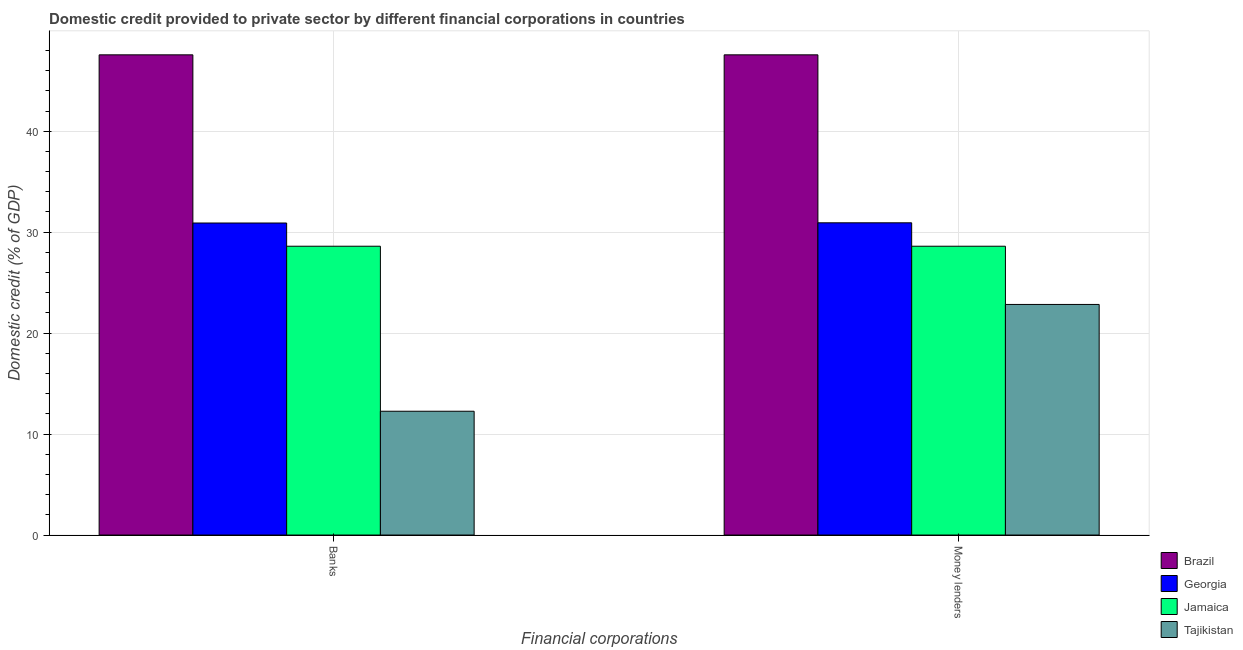How many different coloured bars are there?
Give a very brief answer. 4. Are the number of bars per tick equal to the number of legend labels?
Ensure brevity in your answer.  Yes. Are the number of bars on each tick of the X-axis equal?
Your answer should be compact. Yes. How many bars are there on the 1st tick from the left?
Keep it short and to the point. 4. How many bars are there on the 2nd tick from the right?
Your response must be concise. 4. What is the label of the 2nd group of bars from the left?
Your response must be concise. Money lenders. What is the domestic credit provided by money lenders in Tajikistan?
Your response must be concise. 22.84. Across all countries, what is the maximum domestic credit provided by money lenders?
Provide a short and direct response. 47.56. Across all countries, what is the minimum domestic credit provided by banks?
Make the answer very short. 12.26. In which country was the domestic credit provided by banks maximum?
Your answer should be compact. Brazil. In which country was the domestic credit provided by money lenders minimum?
Ensure brevity in your answer.  Tajikistan. What is the total domestic credit provided by banks in the graph?
Ensure brevity in your answer.  119.34. What is the difference between the domestic credit provided by banks in Tajikistan and that in Brazil?
Make the answer very short. -35.3. What is the difference between the domestic credit provided by money lenders in Jamaica and the domestic credit provided by banks in Georgia?
Give a very brief answer. -2.3. What is the average domestic credit provided by money lenders per country?
Your response must be concise. 32.48. What is the difference between the domestic credit provided by money lenders and domestic credit provided by banks in Jamaica?
Your answer should be compact. 0. What is the ratio of the domestic credit provided by banks in Georgia to that in Tajikistan?
Give a very brief answer. 2.52. Is the domestic credit provided by money lenders in Tajikistan less than that in Brazil?
Your response must be concise. Yes. What does the 4th bar from the right in Banks represents?
Make the answer very short. Brazil. How many countries are there in the graph?
Provide a succinct answer. 4. Are the values on the major ticks of Y-axis written in scientific E-notation?
Keep it short and to the point. No. Does the graph contain grids?
Make the answer very short. Yes. How many legend labels are there?
Provide a short and direct response. 4. What is the title of the graph?
Your answer should be very brief. Domestic credit provided to private sector by different financial corporations in countries. What is the label or title of the X-axis?
Keep it short and to the point. Financial corporations. What is the label or title of the Y-axis?
Your answer should be compact. Domestic credit (% of GDP). What is the Domestic credit (% of GDP) in Brazil in Banks?
Your answer should be compact. 47.56. What is the Domestic credit (% of GDP) in Georgia in Banks?
Provide a succinct answer. 30.91. What is the Domestic credit (% of GDP) of Jamaica in Banks?
Your response must be concise. 28.61. What is the Domestic credit (% of GDP) in Tajikistan in Banks?
Ensure brevity in your answer.  12.26. What is the Domestic credit (% of GDP) in Brazil in Money lenders?
Keep it short and to the point. 47.56. What is the Domestic credit (% of GDP) of Georgia in Money lenders?
Keep it short and to the point. 30.93. What is the Domestic credit (% of GDP) in Jamaica in Money lenders?
Provide a short and direct response. 28.61. What is the Domestic credit (% of GDP) of Tajikistan in Money lenders?
Ensure brevity in your answer.  22.84. Across all Financial corporations, what is the maximum Domestic credit (% of GDP) in Brazil?
Give a very brief answer. 47.56. Across all Financial corporations, what is the maximum Domestic credit (% of GDP) in Georgia?
Give a very brief answer. 30.93. Across all Financial corporations, what is the maximum Domestic credit (% of GDP) in Jamaica?
Provide a short and direct response. 28.61. Across all Financial corporations, what is the maximum Domestic credit (% of GDP) of Tajikistan?
Keep it short and to the point. 22.84. Across all Financial corporations, what is the minimum Domestic credit (% of GDP) in Brazil?
Provide a succinct answer. 47.56. Across all Financial corporations, what is the minimum Domestic credit (% of GDP) in Georgia?
Your answer should be compact. 30.91. Across all Financial corporations, what is the minimum Domestic credit (% of GDP) of Jamaica?
Keep it short and to the point. 28.61. Across all Financial corporations, what is the minimum Domestic credit (% of GDP) of Tajikistan?
Make the answer very short. 12.26. What is the total Domestic credit (% of GDP) in Brazil in the graph?
Your answer should be very brief. 95.13. What is the total Domestic credit (% of GDP) in Georgia in the graph?
Offer a terse response. 61.83. What is the total Domestic credit (% of GDP) in Jamaica in the graph?
Give a very brief answer. 57.21. What is the total Domestic credit (% of GDP) in Tajikistan in the graph?
Ensure brevity in your answer.  35.1. What is the difference between the Domestic credit (% of GDP) of Brazil in Banks and that in Money lenders?
Offer a very short reply. 0. What is the difference between the Domestic credit (% of GDP) of Georgia in Banks and that in Money lenders?
Your answer should be compact. -0.02. What is the difference between the Domestic credit (% of GDP) of Jamaica in Banks and that in Money lenders?
Your response must be concise. 0. What is the difference between the Domestic credit (% of GDP) in Tajikistan in Banks and that in Money lenders?
Make the answer very short. -10.58. What is the difference between the Domestic credit (% of GDP) in Brazil in Banks and the Domestic credit (% of GDP) in Georgia in Money lenders?
Ensure brevity in your answer.  16.64. What is the difference between the Domestic credit (% of GDP) of Brazil in Banks and the Domestic credit (% of GDP) of Jamaica in Money lenders?
Make the answer very short. 18.96. What is the difference between the Domestic credit (% of GDP) in Brazil in Banks and the Domestic credit (% of GDP) in Tajikistan in Money lenders?
Your answer should be very brief. 24.72. What is the difference between the Domestic credit (% of GDP) of Georgia in Banks and the Domestic credit (% of GDP) of Jamaica in Money lenders?
Offer a very short reply. 2.3. What is the difference between the Domestic credit (% of GDP) of Georgia in Banks and the Domestic credit (% of GDP) of Tajikistan in Money lenders?
Give a very brief answer. 8.07. What is the difference between the Domestic credit (% of GDP) of Jamaica in Banks and the Domestic credit (% of GDP) of Tajikistan in Money lenders?
Make the answer very short. 5.77. What is the average Domestic credit (% of GDP) in Brazil per Financial corporations?
Ensure brevity in your answer.  47.56. What is the average Domestic credit (% of GDP) in Georgia per Financial corporations?
Offer a terse response. 30.92. What is the average Domestic credit (% of GDP) in Jamaica per Financial corporations?
Provide a succinct answer. 28.61. What is the average Domestic credit (% of GDP) of Tajikistan per Financial corporations?
Provide a short and direct response. 17.55. What is the difference between the Domestic credit (% of GDP) in Brazil and Domestic credit (% of GDP) in Georgia in Banks?
Your response must be concise. 16.66. What is the difference between the Domestic credit (% of GDP) in Brazil and Domestic credit (% of GDP) in Jamaica in Banks?
Ensure brevity in your answer.  18.96. What is the difference between the Domestic credit (% of GDP) of Brazil and Domestic credit (% of GDP) of Tajikistan in Banks?
Your answer should be compact. 35.3. What is the difference between the Domestic credit (% of GDP) in Georgia and Domestic credit (% of GDP) in Jamaica in Banks?
Ensure brevity in your answer.  2.3. What is the difference between the Domestic credit (% of GDP) of Georgia and Domestic credit (% of GDP) of Tajikistan in Banks?
Provide a short and direct response. 18.64. What is the difference between the Domestic credit (% of GDP) in Jamaica and Domestic credit (% of GDP) in Tajikistan in Banks?
Provide a succinct answer. 16.34. What is the difference between the Domestic credit (% of GDP) of Brazil and Domestic credit (% of GDP) of Georgia in Money lenders?
Provide a short and direct response. 16.64. What is the difference between the Domestic credit (% of GDP) of Brazil and Domestic credit (% of GDP) of Jamaica in Money lenders?
Your answer should be compact. 18.96. What is the difference between the Domestic credit (% of GDP) in Brazil and Domestic credit (% of GDP) in Tajikistan in Money lenders?
Make the answer very short. 24.72. What is the difference between the Domestic credit (% of GDP) of Georgia and Domestic credit (% of GDP) of Jamaica in Money lenders?
Keep it short and to the point. 2.32. What is the difference between the Domestic credit (% of GDP) in Georgia and Domestic credit (% of GDP) in Tajikistan in Money lenders?
Offer a terse response. 8.09. What is the difference between the Domestic credit (% of GDP) of Jamaica and Domestic credit (% of GDP) of Tajikistan in Money lenders?
Offer a terse response. 5.77. What is the ratio of the Domestic credit (% of GDP) of Brazil in Banks to that in Money lenders?
Your answer should be very brief. 1. What is the ratio of the Domestic credit (% of GDP) of Georgia in Banks to that in Money lenders?
Offer a terse response. 1. What is the ratio of the Domestic credit (% of GDP) of Jamaica in Banks to that in Money lenders?
Offer a very short reply. 1. What is the ratio of the Domestic credit (% of GDP) of Tajikistan in Banks to that in Money lenders?
Provide a short and direct response. 0.54. What is the difference between the highest and the second highest Domestic credit (% of GDP) of Brazil?
Provide a succinct answer. 0. What is the difference between the highest and the second highest Domestic credit (% of GDP) in Georgia?
Your answer should be very brief. 0.02. What is the difference between the highest and the second highest Domestic credit (% of GDP) in Jamaica?
Make the answer very short. 0. What is the difference between the highest and the second highest Domestic credit (% of GDP) in Tajikistan?
Offer a terse response. 10.58. What is the difference between the highest and the lowest Domestic credit (% of GDP) of Brazil?
Offer a terse response. 0. What is the difference between the highest and the lowest Domestic credit (% of GDP) of Georgia?
Ensure brevity in your answer.  0.02. What is the difference between the highest and the lowest Domestic credit (% of GDP) of Tajikistan?
Offer a very short reply. 10.58. 